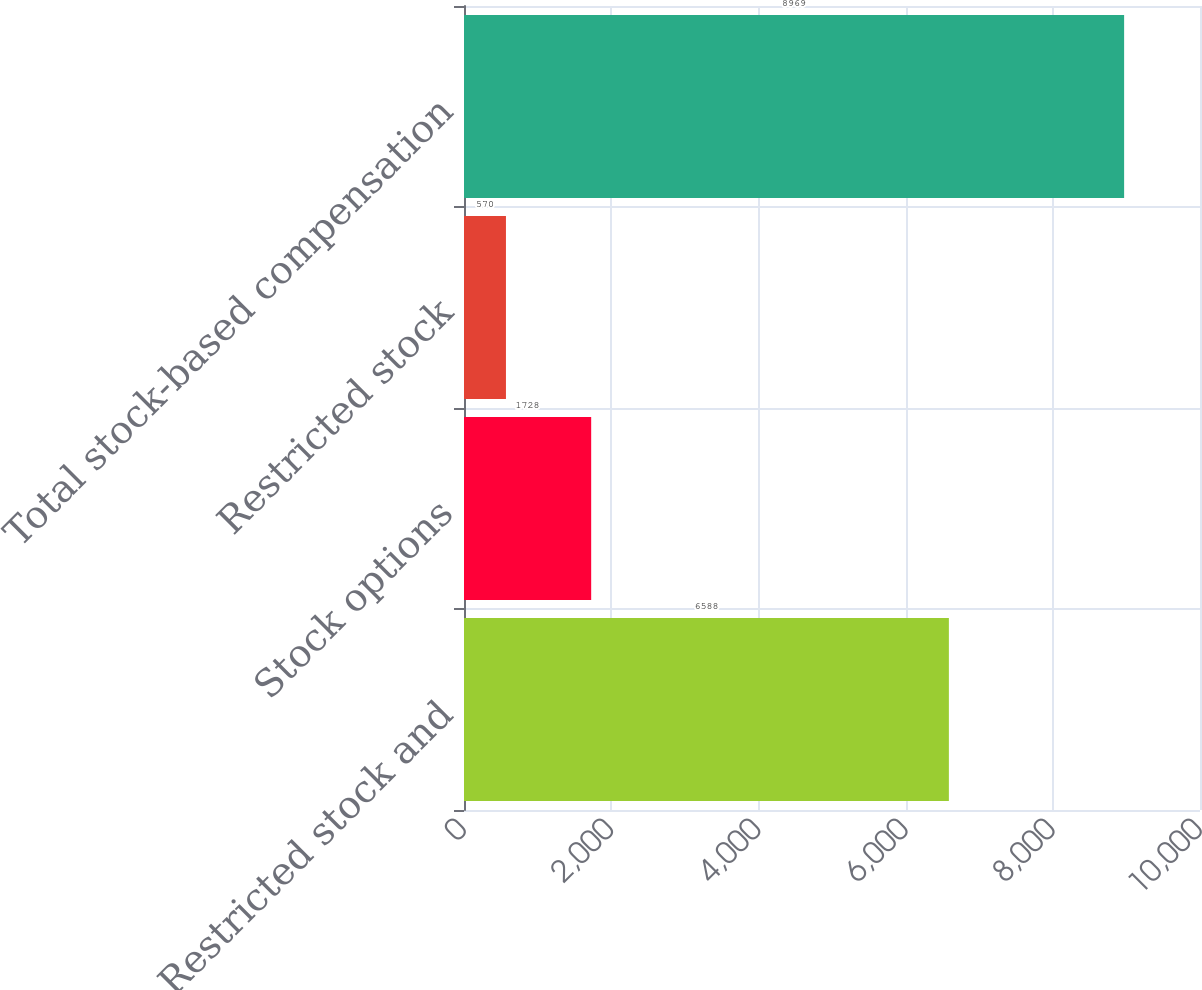Convert chart. <chart><loc_0><loc_0><loc_500><loc_500><bar_chart><fcel>Restricted stock and<fcel>Stock options<fcel>Restricted stock<fcel>Total stock-based compensation<nl><fcel>6588<fcel>1728<fcel>570<fcel>8969<nl></chart> 